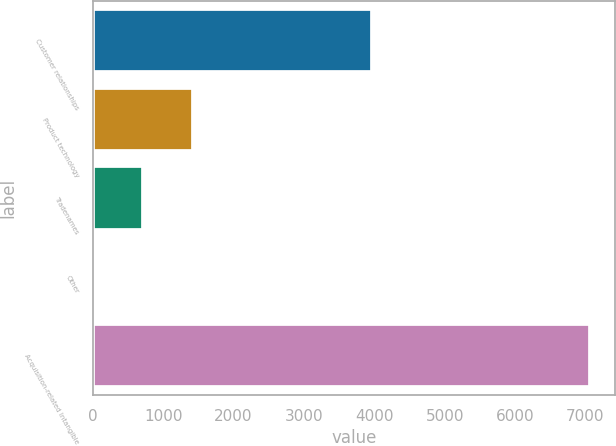Convert chart to OTSL. <chart><loc_0><loc_0><loc_500><loc_500><bar_chart><fcel>Customer relationships<fcel>Product technology<fcel>Tradenames<fcel>Other<fcel>Acquisition-related Intangible<nl><fcel>3967<fcel>1416.02<fcel>709.11<fcel>2.2<fcel>7071.3<nl></chart> 